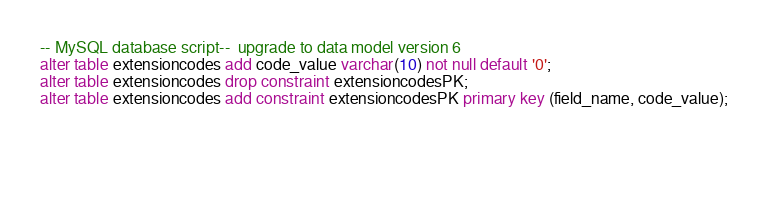<code> <loc_0><loc_0><loc_500><loc_500><_SQL_>-- MySQL database script--  upgrade to data model version 6
alter table extensioncodes add code_value varchar(10) not null default '0';
alter table extensioncodes drop constraint extensioncodesPK;
alter table extensioncodes add constraint extensioncodesPK primary key (field_name, code_value);

 

	
</code> 